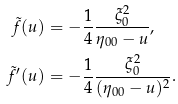Convert formula to latex. <formula><loc_0><loc_0><loc_500><loc_500>\tilde { f } ( u ) & = - \frac { 1 } { 4 } \frac { \xi _ { 0 } ^ { 2 } } { \eta _ { 0 0 } - u } , \\ \tilde { f } ^ { \prime } ( u ) & = - \frac { 1 } { 4 } \frac { \xi _ { 0 } ^ { 2 } } { ( \eta _ { 0 0 } - u ) ^ { 2 } } .</formula> 